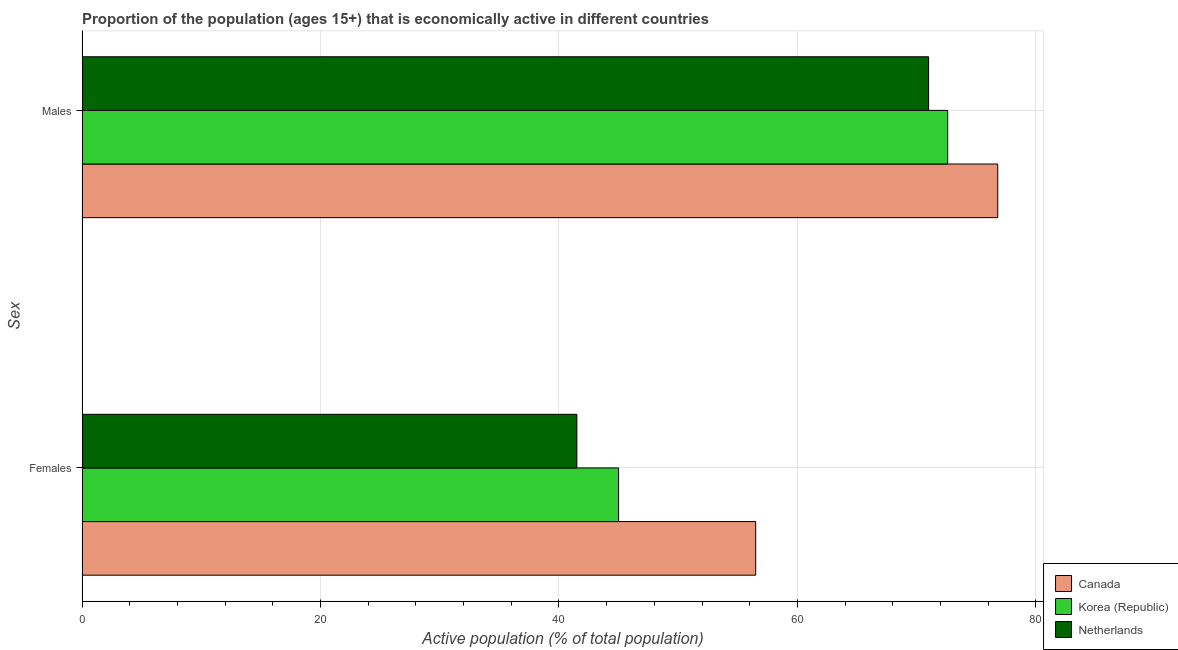How many bars are there on the 2nd tick from the top?
Ensure brevity in your answer.  3. How many bars are there on the 1st tick from the bottom?
Ensure brevity in your answer.  3. What is the label of the 1st group of bars from the top?
Ensure brevity in your answer.  Males. What is the percentage of economically active female population in Netherlands?
Offer a very short reply. 41.5. Across all countries, what is the maximum percentage of economically active male population?
Your answer should be very brief. 76.8. In which country was the percentage of economically active female population maximum?
Provide a succinct answer. Canada. In which country was the percentage of economically active male population minimum?
Your answer should be very brief. Netherlands. What is the total percentage of economically active female population in the graph?
Ensure brevity in your answer.  143. What is the difference between the percentage of economically active female population in Canada and that in Korea (Republic)?
Your answer should be very brief. 11.5. What is the average percentage of economically active female population per country?
Keep it short and to the point. 47.67. What is the difference between the percentage of economically active male population and percentage of economically active female population in Korea (Republic)?
Make the answer very short. 27.6. In how many countries, is the percentage of economically active male population greater than 72 %?
Ensure brevity in your answer.  2. What is the ratio of the percentage of economically active male population in Korea (Republic) to that in Canada?
Your answer should be compact. 0.95. How many bars are there?
Ensure brevity in your answer.  6. How many countries are there in the graph?
Offer a terse response. 3. Where does the legend appear in the graph?
Offer a very short reply. Bottom right. How are the legend labels stacked?
Your answer should be compact. Vertical. What is the title of the graph?
Provide a short and direct response. Proportion of the population (ages 15+) that is economically active in different countries. What is the label or title of the X-axis?
Offer a terse response. Active population (% of total population). What is the label or title of the Y-axis?
Make the answer very short. Sex. What is the Active population (% of total population) of Canada in Females?
Your response must be concise. 56.5. What is the Active population (% of total population) of Korea (Republic) in Females?
Make the answer very short. 45. What is the Active population (% of total population) in Netherlands in Females?
Make the answer very short. 41.5. What is the Active population (% of total population) in Canada in Males?
Keep it short and to the point. 76.8. What is the Active population (% of total population) in Korea (Republic) in Males?
Offer a terse response. 72.6. What is the Active population (% of total population) in Netherlands in Males?
Provide a succinct answer. 71. Across all Sex, what is the maximum Active population (% of total population) of Canada?
Provide a short and direct response. 76.8. Across all Sex, what is the maximum Active population (% of total population) of Korea (Republic)?
Offer a very short reply. 72.6. Across all Sex, what is the maximum Active population (% of total population) in Netherlands?
Your answer should be very brief. 71. Across all Sex, what is the minimum Active population (% of total population) of Canada?
Provide a succinct answer. 56.5. Across all Sex, what is the minimum Active population (% of total population) in Netherlands?
Provide a succinct answer. 41.5. What is the total Active population (% of total population) of Canada in the graph?
Provide a succinct answer. 133.3. What is the total Active population (% of total population) in Korea (Republic) in the graph?
Give a very brief answer. 117.6. What is the total Active population (% of total population) of Netherlands in the graph?
Give a very brief answer. 112.5. What is the difference between the Active population (% of total population) of Canada in Females and that in Males?
Provide a succinct answer. -20.3. What is the difference between the Active population (% of total population) in Korea (Republic) in Females and that in Males?
Make the answer very short. -27.6. What is the difference between the Active population (% of total population) of Netherlands in Females and that in Males?
Your answer should be very brief. -29.5. What is the difference between the Active population (% of total population) of Canada in Females and the Active population (% of total population) of Korea (Republic) in Males?
Offer a terse response. -16.1. What is the difference between the Active population (% of total population) of Korea (Republic) in Females and the Active population (% of total population) of Netherlands in Males?
Your response must be concise. -26. What is the average Active population (% of total population) of Canada per Sex?
Keep it short and to the point. 66.65. What is the average Active population (% of total population) of Korea (Republic) per Sex?
Keep it short and to the point. 58.8. What is the average Active population (% of total population) of Netherlands per Sex?
Your answer should be compact. 56.25. What is the difference between the Active population (% of total population) in Canada and Active population (% of total population) in Korea (Republic) in Females?
Provide a succinct answer. 11.5. What is the difference between the Active population (% of total population) of Canada and Active population (% of total population) of Netherlands in Females?
Your answer should be compact. 15. What is the difference between the Active population (% of total population) of Korea (Republic) and Active population (% of total population) of Netherlands in Females?
Keep it short and to the point. 3.5. What is the difference between the Active population (% of total population) in Canada and Active population (% of total population) in Korea (Republic) in Males?
Provide a short and direct response. 4.2. What is the difference between the Active population (% of total population) in Korea (Republic) and Active population (% of total population) in Netherlands in Males?
Offer a terse response. 1.6. What is the ratio of the Active population (% of total population) of Canada in Females to that in Males?
Your response must be concise. 0.74. What is the ratio of the Active population (% of total population) in Korea (Republic) in Females to that in Males?
Your answer should be compact. 0.62. What is the ratio of the Active population (% of total population) in Netherlands in Females to that in Males?
Ensure brevity in your answer.  0.58. What is the difference between the highest and the second highest Active population (% of total population) in Canada?
Your answer should be very brief. 20.3. What is the difference between the highest and the second highest Active population (% of total population) in Korea (Republic)?
Your answer should be compact. 27.6. What is the difference between the highest and the second highest Active population (% of total population) of Netherlands?
Offer a terse response. 29.5. What is the difference between the highest and the lowest Active population (% of total population) of Canada?
Keep it short and to the point. 20.3. What is the difference between the highest and the lowest Active population (% of total population) in Korea (Republic)?
Ensure brevity in your answer.  27.6. What is the difference between the highest and the lowest Active population (% of total population) of Netherlands?
Your response must be concise. 29.5. 